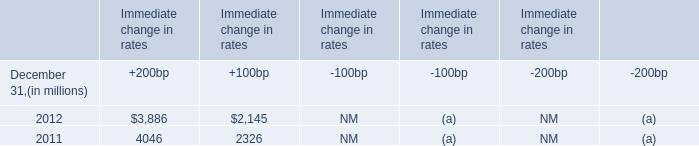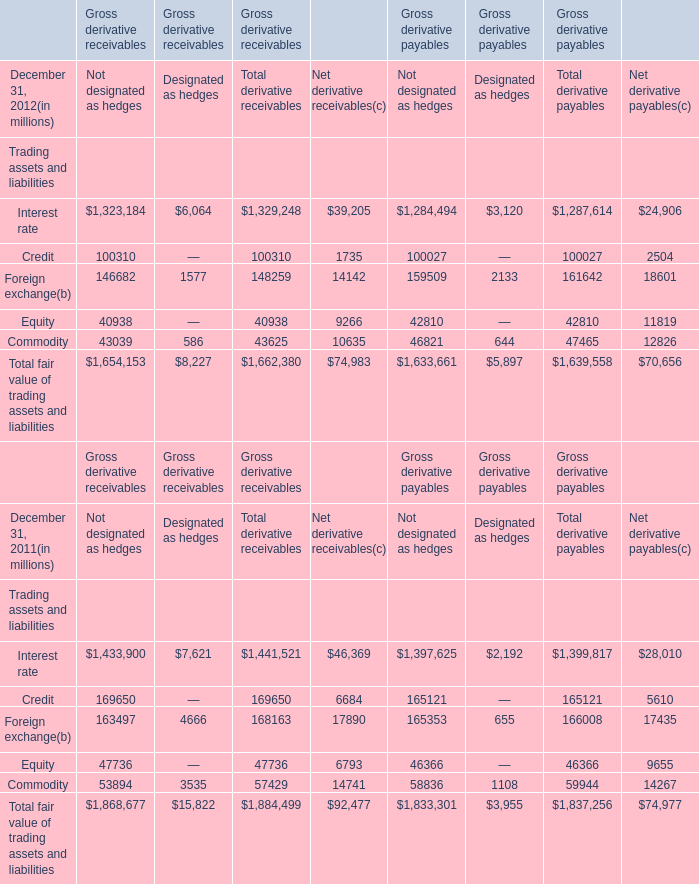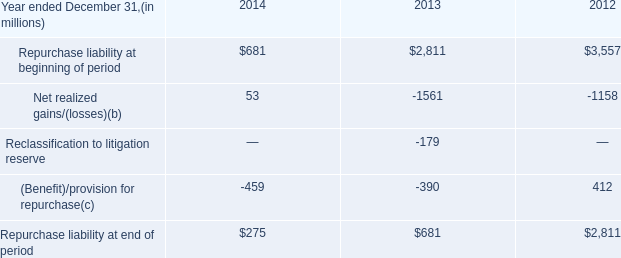In the year with largest amount of Credit for Not designated as hedgeswhat's the increasing rate of Foreign exchange for Gross derivative receivables? 
Computations: ((146682 - 163497) / 163497)
Answer: -0.10285. 